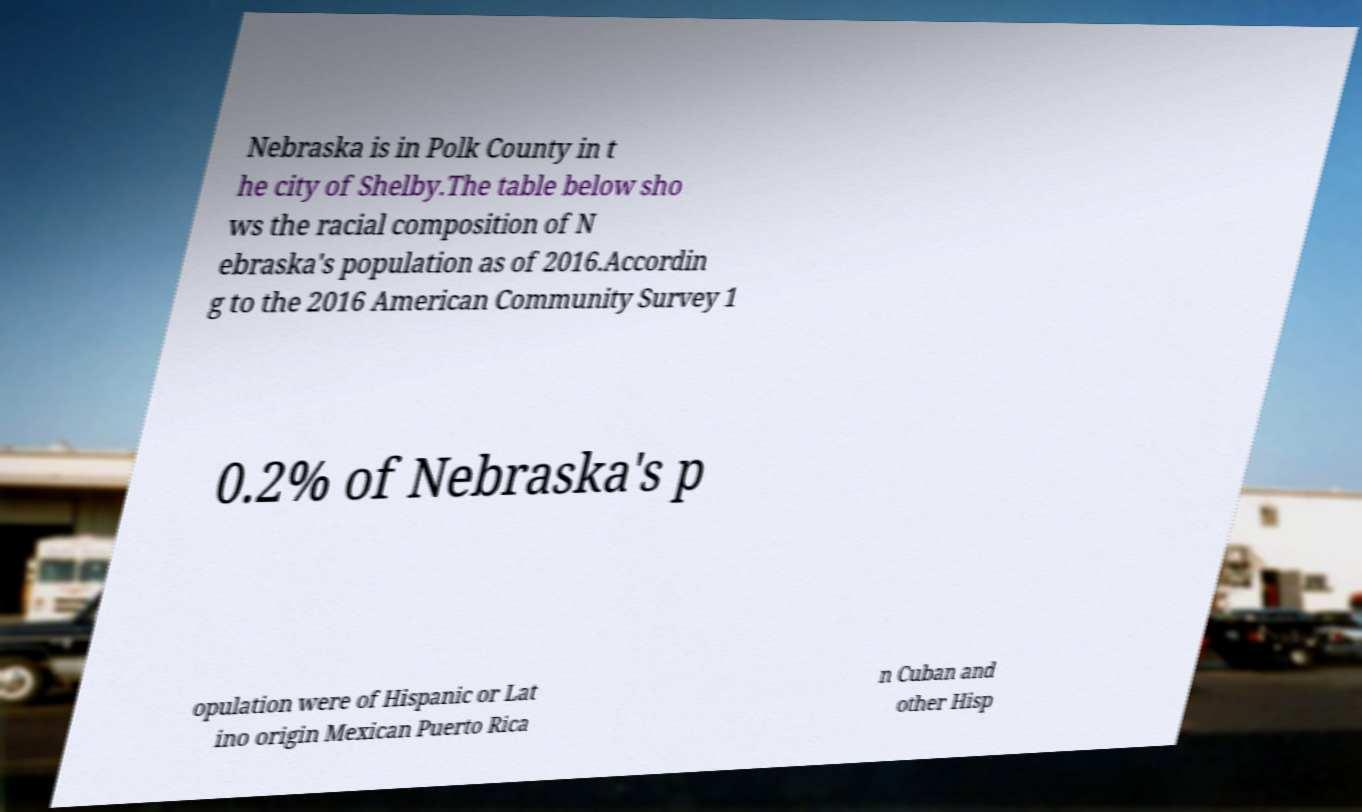Could you assist in decoding the text presented in this image and type it out clearly? Nebraska is in Polk County in t he city of Shelby.The table below sho ws the racial composition of N ebraska's population as of 2016.Accordin g to the 2016 American Community Survey 1 0.2% of Nebraska's p opulation were of Hispanic or Lat ino origin Mexican Puerto Rica n Cuban and other Hisp 